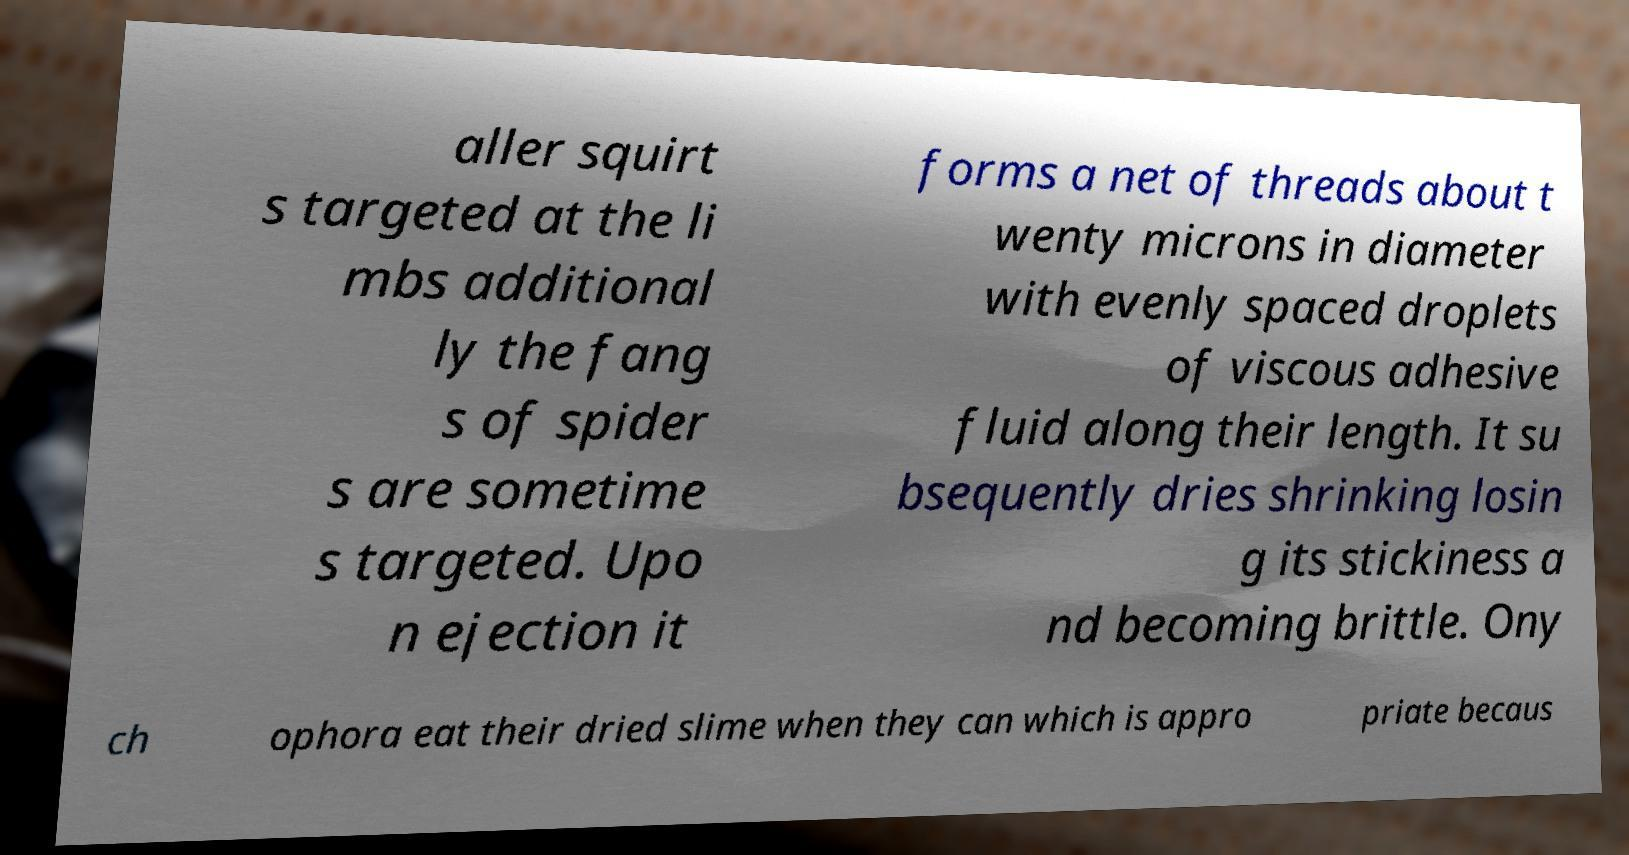Please identify and transcribe the text found in this image. aller squirt s targeted at the li mbs additional ly the fang s of spider s are sometime s targeted. Upo n ejection it forms a net of threads about t wenty microns in diameter with evenly spaced droplets of viscous adhesive fluid along their length. It su bsequently dries shrinking losin g its stickiness a nd becoming brittle. Ony ch ophora eat their dried slime when they can which is appro priate becaus 